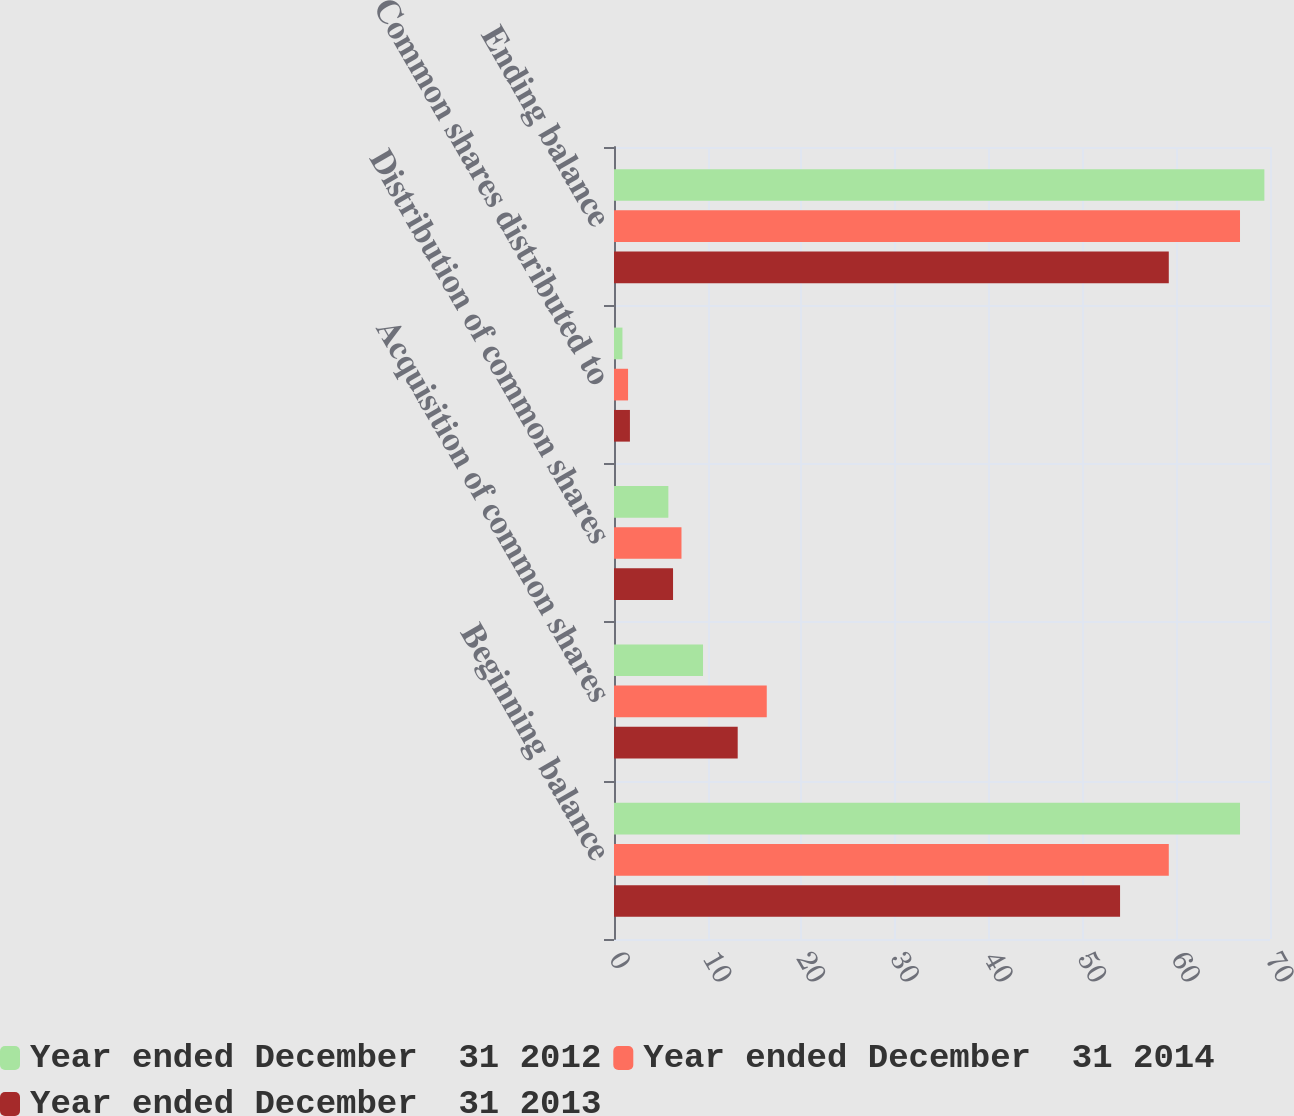<chart> <loc_0><loc_0><loc_500><loc_500><stacked_bar_chart><ecel><fcel>Beginning balance<fcel>Acquisition of common shares<fcel>Distribution of common shares<fcel>Common shares distributed to<fcel>Ending balance<nl><fcel>Year ended December  31 2012<fcel>66.8<fcel>9.5<fcel>5.8<fcel>0.9<fcel>69.4<nl><fcel>Year ended December  31 2014<fcel>59.2<fcel>16.3<fcel>7.2<fcel>1.5<fcel>66.8<nl><fcel>Year ended December  31 2013<fcel>54<fcel>13.2<fcel>6.3<fcel>1.7<fcel>59.2<nl></chart> 